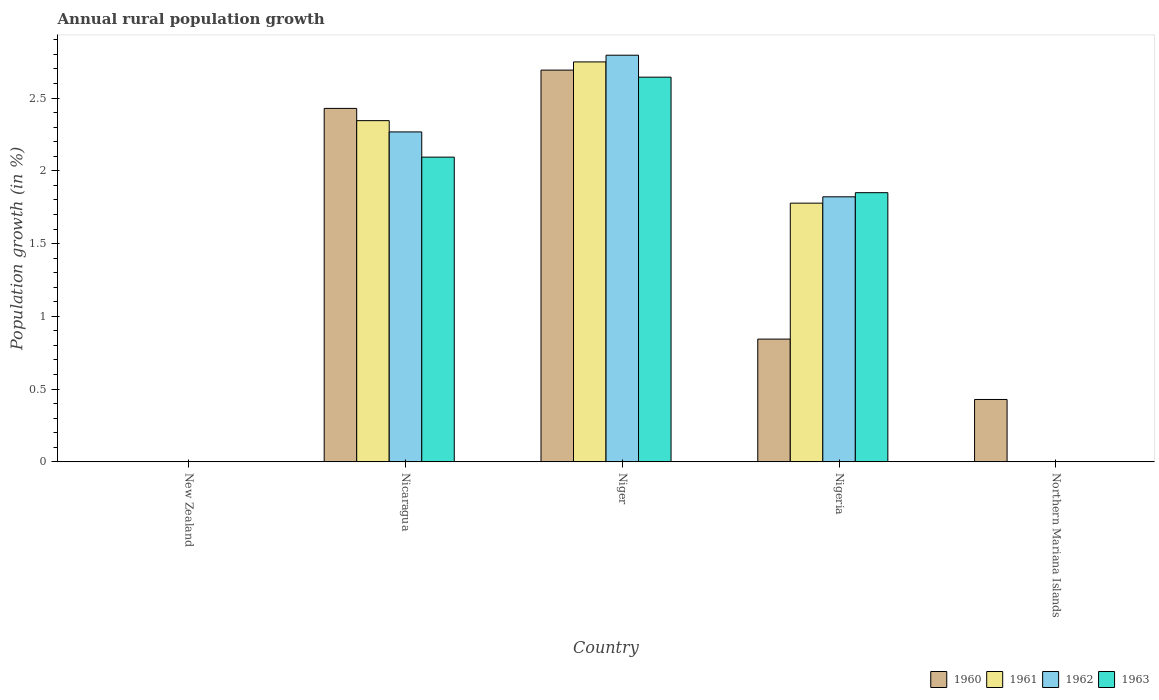How many different coloured bars are there?
Your response must be concise. 4. How many bars are there on the 1st tick from the left?
Your answer should be very brief. 0. How many bars are there on the 1st tick from the right?
Your answer should be very brief. 1. What is the label of the 2nd group of bars from the left?
Provide a succinct answer. Nicaragua. What is the percentage of rural population growth in 1962 in Northern Mariana Islands?
Your response must be concise. 0. Across all countries, what is the maximum percentage of rural population growth in 1962?
Your answer should be compact. 2.79. Across all countries, what is the minimum percentage of rural population growth in 1961?
Provide a succinct answer. 0. In which country was the percentage of rural population growth in 1961 maximum?
Ensure brevity in your answer.  Niger. What is the total percentage of rural population growth in 1962 in the graph?
Provide a short and direct response. 6.88. What is the difference between the percentage of rural population growth in 1963 in Nicaragua and that in Niger?
Keep it short and to the point. -0.55. What is the difference between the percentage of rural population growth in 1963 in Nigeria and the percentage of rural population growth in 1961 in Nicaragua?
Provide a succinct answer. -0.49. What is the average percentage of rural population growth in 1961 per country?
Make the answer very short. 1.37. What is the difference between the percentage of rural population growth of/in 1962 and percentage of rural population growth of/in 1961 in Niger?
Your response must be concise. 0.05. What is the ratio of the percentage of rural population growth in 1960 in Niger to that in Nigeria?
Provide a succinct answer. 3.19. Is the difference between the percentage of rural population growth in 1962 in Nicaragua and Nigeria greater than the difference between the percentage of rural population growth in 1961 in Nicaragua and Nigeria?
Your response must be concise. No. What is the difference between the highest and the second highest percentage of rural population growth in 1961?
Your answer should be compact. -0.97. What is the difference between the highest and the lowest percentage of rural population growth in 1961?
Ensure brevity in your answer.  2.75. Is it the case that in every country, the sum of the percentage of rural population growth in 1961 and percentage of rural population growth in 1963 is greater than the sum of percentage of rural population growth in 1960 and percentage of rural population growth in 1962?
Make the answer very short. No. How many bars are there?
Provide a short and direct response. 13. Are all the bars in the graph horizontal?
Keep it short and to the point. No. What is the difference between two consecutive major ticks on the Y-axis?
Your answer should be compact. 0.5. Are the values on the major ticks of Y-axis written in scientific E-notation?
Give a very brief answer. No. Does the graph contain grids?
Give a very brief answer. No. Where does the legend appear in the graph?
Your answer should be compact. Bottom right. How many legend labels are there?
Your answer should be very brief. 4. What is the title of the graph?
Your answer should be very brief. Annual rural population growth. What is the label or title of the Y-axis?
Provide a succinct answer. Population growth (in %). What is the Population growth (in %) in 1961 in New Zealand?
Provide a short and direct response. 0. What is the Population growth (in %) in 1962 in New Zealand?
Provide a short and direct response. 0. What is the Population growth (in %) in 1963 in New Zealand?
Keep it short and to the point. 0. What is the Population growth (in %) of 1960 in Nicaragua?
Your answer should be very brief. 2.43. What is the Population growth (in %) in 1961 in Nicaragua?
Your answer should be compact. 2.34. What is the Population growth (in %) in 1962 in Nicaragua?
Keep it short and to the point. 2.27. What is the Population growth (in %) in 1963 in Nicaragua?
Your answer should be compact. 2.09. What is the Population growth (in %) of 1960 in Niger?
Your answer should be very brief. 2.69. What is the Population growth (in %) in 1961 in Niger?
Make the answer very short. 2.75. What is the Population growth (in %) of 1962 in Niger?
Keep it short and to the point. 2.79. What is the Population growth (in %) of 1963 in Niger?
Provide a short and direct response. 2.64. What is the Population growth (in %) in 1960 in Nigeria?
Your response must be concise. 0.84. What is the Population growth (in %) in 1961 in Nigeria?
Offer a terse response. 1.78. What is the Population growth (in %) in 1962 in Nigeria?
Give a very brief answer. 1.82. What is the Population growth (in %) in 1963 in Nigeria?
Provide a short and direct response. 1.85. What is the Population growth (in %) of 1960 in Northern Mariana Islands?
Provide a short and direct response. 0.43. What is the Population growth (in %) of 1962 in Northern Mariana Islands?
Ensure brevity in your answer.  0. Across all countries, what is the maximum Population growth (in %) of 1960?
Provide a short and direct response. 2.69. Across all countries, what is the maximum Population growth (in %) in 1961?
Keep it short and to the point. 2.75. Across all countries, what is the maximum Population growth (in %) in 1962?
Your answer should be compact. 2.79. Across all countries, what is the maximum Population growth (in %) in 1963?
Your response must be concise. 2.64. Across all countries, what is the minimum Population growth (in %) of 1962?
Give a very brief answer. 0. Across all countries, what is the minimum Population growth (in %) in 1963?
Provide a short and direct response. 0. What is the total Population growth (in %) of 1960 in the graph?
Ensure brevity in your answer.  6.39. What is the total Population growth (in %) in 1961 in the graph?
Ensure brevity in your answer.  6.87. What is the total Population growth (in %) in 1962 in the graph?
Ensure brevity in your answer.  6.88. What is the total Population growth (in %) of 1963 in the graph?
Your response must be concise. 6.59. What is the difference between the Population growth (in %) of 1960 in Nicaragua and that in Niger?
Provide a short and direct response. -0.26. What is the difference between the Population growth (in %) of 1961 in Nicaragua and that in Niger?
Your response must be concise. -0.4. What is the difference between the Population growth (in %) in 1962 in Nicaragua and that in Niger?
Provide a short and direct response. -0.53. What is the difference between the Population growth (in %) of 1963 in Nicaragua and that in Niger?
Provide a short and direct response. -0.55. What is the difference between the Population growth (in %) in 1960 in Nicaragua and that in Nigeria?
Keep it short and to the point. 1.59. What is the difference between the Population growth (in %) of 1961 in Nicaragua and that in Nigeria?
Give a very brief answer. 0.57. What is the difference between the Population growth (in %) in 1962 in Nicaragua and that in Nigeria?
Offer a terse response. 0.45. What is the difference between the Population growth (in %) of 1963 in Nicaragua and that in Nigeria?
Keep it short and to the point. 0.24. What is the difference between the Population growth (in %) in 1960 in Nicaragua and that in Northern Mariana Islands?
Offer a terse response. 2. What is the difference between the Population growth (in %) in 1960 in Niger and that in Nigeria?
Give a very brief answer. 1.85. What is the difference between the Population growth (in %) of 1961 in Niger and that in Nigeria?
Offer a terse response. 0.97. What is the difference between the Population growth (in %) of 1962 in Niger and that in Nigeria?
Provide a succinct answer. 0.97. What is the difference between the Population growth (in %) of 1963 in Niger and that in Nigeria?
Give a very brief answer. 0.79. What is the difference between the Population growth (in %) in 1960 in Niger and that in Northern Mariana Islands?
Provide a succinct answer. 2.26. What is the difference between the Population growth (in %) in 1960 in Nigeria and that in Northern Mariana Islands?
Your response must be concise. 0.41. What is the difference between the Population growth (in %) in 1960 in Nicaragua and the Population growth (in %) in 1961 in Niger?
Provide a succinct answer. -0.32. What is the difference between the Population growth (in %) in 1960 in Nicaragua and the Population growth (in %) in 1962 in Niger?
Make the answer very short. -0.37. What is the difference between the Population growth (in %) of 1960 in Nicaragua and the Population growth (in %) of 1963 in Niger?
Give a very brief answer. -0.21. What is the difference between the Population growth (in %) in 1961 in Nicaragua and the Population growth (in %) in 1962 in Niger?
Offer a terse response. -0.45. What is the difference between the Population growth (in %) in 1961 in Nicaragua and the Population growth (in %) in 1963 in Niger?
Provide a succinct answer. -0.3. What is the difference between the Population growth (in %) of 1962 in Nicaragua and the Population growth (in %) of 1963 in Niger?
Offer a very short reply. -0.38. What is the difference between the Population growth (in %) of 1960 in Nicaragua and the Population growth (in %) of 1961 in Nigeria?
Offer a terse response. 0.65. What is the difference between the Population growth (in %) of 1960 in Nicaragua and the Population growth (in %) of 1962 in Nigeria?
Provide a succinct answer. 0.61. What is the difference between the Population growth (in %) of 1960 in Nicaragua and the Population growth (in %) of 1963 in Nigeria?
Provide a short and direct response. 0.58. What is the difference between the Population growth (in %) of 1961 in Nicaragua and the Population growth (in %) of 1962 in Nigeria?
Your response must be concise. 0.52. What is the difference between the Population growth (in %) of 1961 in Nicaragua and the Population growth (in %) of 1963 in Nigeria?
Provide a short and direct response. 0.49. What is the difference between the Population growth (in %) of 1962 in Nicaragua and the Population growth (in %) of 1963 in Nigeria?
Your answer should be very brief. 0.42. What is the difference between the Population growth (in %) in 1960 in Niger and the Population growth (in %) in 1961 in Nigeria?
Provide a succinct answer. 0.91. What is the difference between the Population growth (in %) in 1960 in Niger and the Population growth (in %) in 1962 in Nigeria?
Offer a very short reply. 0.87. What is the difference between the Population growth (in %) in 1960 in Niger and the Population growth (in %) in 1963 in Nigeria?
Your response must be concise. 0.84. What is the difference between the Population growth (in %) of 1961 in Niger and the Population growth (in %) of 1962 in Nigeria?
Provide a short and direct response. 0.93. What is the difference between the Population growth (in %) of 1961 in Niger and the Population growth (in %) of 1963 in Nigeria?
Give a very brief answer. 0.9. What is the difference between the Population growth (in %) of 1962 in Niger and the Population growth (in %) of 1963 in Nigeria?
Give a very brief answer. 0.94. What is the average Population growth (in %) of 1960 per country?
Provide a short and direct response. 1.28. What is the average Population growth (in %) in 1961 per country?
Your response must be concise. 1.37. What is the average Population growth (in %) in 1962 per country?
Ensure brevity in your answer.  1.38. What is the average Population growth (in %) of 1963 per country?
Your answer should be compact. 1.32. What is the difference between the Population growth (in %) in 1960 and Population growth (in %) in 1961 in Nicaragua?
Your answer should be very brief. 0.08. What is the difference between the Population growth (in %) of 1960 and Population growth (in %) of 1962 in Nicaragua?
Ensure brevity in your answer.  0.16. What is the difference between the Population growth (in %) of 1960 and Population growth (in %) of 1963 in Nicaragua?
Your answer should be very brief. 0.33. What is the difference between the Population growth (in %) in 1961 and Population growth (in %) in 1962 in Nicaragua?
Provide a succinct answer. 0.08. What is the difference between the Population growth (in %) of 1961 and Population growth (in %) of 1963 in Nicaragua?
Your answer should be very brief. 0.25. What is the difference between the Population growth (in %) of 1962 and Population growth (in %) of 1963 in Nicaragua?
Ensure brevity in your answer.  0.17. What is the difference between the Population growth (in %) of 1960 and Population growth (in %) of 1961 in Niger?
Give a very brief answer. -0.06. What is the difference between the Population growth (in %) in 1960 and Population growth (in %) in 1962 in Niger?
Provide a succinct answer. -0.1. What is the difference between the Population growth (in %) in 1960 and Population growth (in %) in 1963 in Niger?
Ensure brevity in your answer.  0.05. What is the difference between the Population growth (in %) in 1961 and Population growth (in %) in 1962 in Niger?
Your answer should be compact. -0.05. What is the difference between the Population growth (in %) of 1961 and Population growth (in %) of 1963 in Niger?
Offer a very short reply. 0.1. What is the difference between the Population growth (in %) in 1962 and Population growth (in %) in 1963 in Niger?
Your response must be concise. 0.15. What is the difference between the Population growth (in %) in 1960 and Population growth (in %) in 1961 in Nigeria?
Make the answer very short. -0.93. What is the difference between the Population growth (in %) in 1960 and Population growth (in %) in 1962 in Nigeria?
Give a very brief answer. -0.98. What is the difference between the Population growth (in %) of 1960 and Population growth (in %) of 1963 in Nigeria?
Your answer should be compact. -1.01. What is the difference between the Population growth (in %) in 1961 and Population growth (in %) in 1962 in Nigeria?
Offer a very short reply. -0.04. What is the difference between the Population growth (in %) of 1961 and Population growth (in %) of 1963 in Nigeria?
Provide a short and direct response. -0.07. What is the difference between the Population growth (in %) in 1962 and Population growth (in %) in 1963 in Nigeria?
Offer a terse response. -0.03. What is the ratio of the Population growth (in %) of 1960 in Nicaragua to that in Niger?
Give a very brief answer. 0.9. What is the ratio of the Population growth (in %) of 1961 in Nicaragua to that in Niger?
Provide a short and direct response. 0.85. What is the ratio of the Population growth (in %) of 1962 in Nicaragua to that in Niger?
Provide a short and direct response. 0.81. What is the ratio of the Population growth (in %) in 1963 in Nicaragua to that in Niger?
Ensure brevity in your answer.  0.79. What is the ratio of the Population growth (in %) of 1960 in Nicaragua to that in Nigeria?
Make the answer very short. 2.88. What is the ratio of the Population growth (in %) of 1961 in Nicaragua to that in Nigeria?
Keep it short and to the point. 1.32. What is the ratio of the Population growth (in %) in 1962 in Nicaragua to that in Nigeria?
Make the answer very short. 1.24. What is the ratio of the Population growth (in %) in 1963 in Nicaragua to that in Nigeria?
Offer a terse response. 1.13. What is the ratio of the Population growth (in %) in 1960 in Nicaragua to that in Northern Mariana Islands?
Your answer should be compact. 5.67. What is the ratio of the Population growth (in %) of 1960 in Niger to that in Nigeria?
Make the answer very short. 3.19. What is the ratio of the Population growth (in %) in 1961 in Niger to that in Nigeria?
Keep it short and to the point. 1.55. What is the ratio of the Population growth (in %) in 1962 in Niger to that in Nigeria?
Provide a short and direct response. 1.53. What is the ratio of the Population growth (in %) of 1963 in Niger to that in Nigeria?
Keep it short and to the point. 1.43. What is the ratio of the Population growth (in %) in 1960 in Niger to that in Northern Mariana Islands?
Ensure brevity in your answer.  6.28. What is the ratio of the Population growth (in %) of 1960 in Nigeria to that in Northern Mariana Islands?
Your response must be concise. 1.97. What is the difference between the highest and the second highest Population growth (in %) of 1960?
Ensure brevity in your answer.  0.26. What is the difference between the highest and the second highest Population growth (in %) in 1961?
Your response must be concise. 0.4. What is the difference between the highest and the second highest Population growth (in %) in 1962?
Offer a terse response. 0.53. What is the difference between the highest and the second highest Population growth (in %) of 1963?
Your answer should be very brief. 0.55. What is the difference between the highest and the lowest Population growth (in %) in 1960?
Your response must be concise. 2.69. What is the difference between the highest and the lowest Population growth (in %) of 1961?
Give a very brief answer. 2.75. What is the difference between the highest and the lowest Population growth (in %) in 1962?
Your answer should be compact. 2.79. What is the difference between the highest and the lowest Population growth (in %) in 1963?
Your response must be concise. 2.64. 